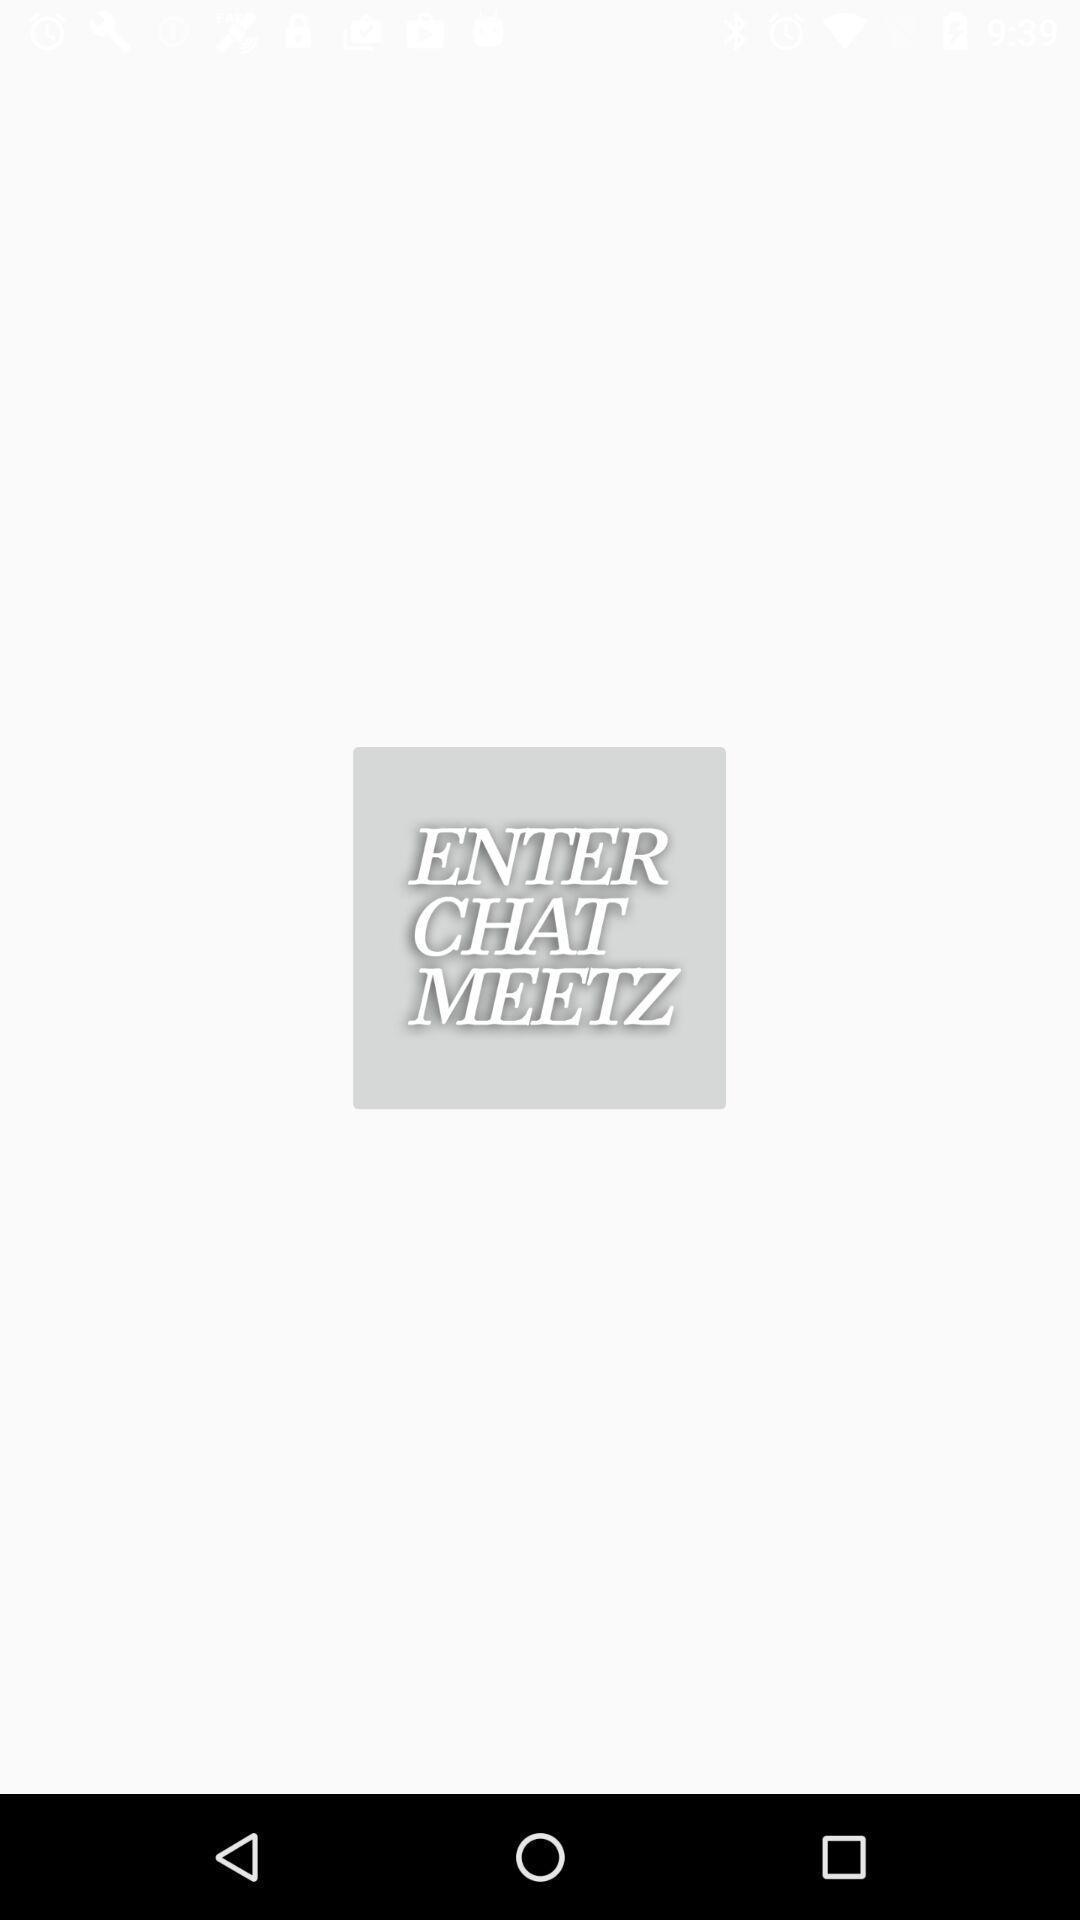Tell me about the visual elements in this screen capture. Page showing to enter a chat conversation. 